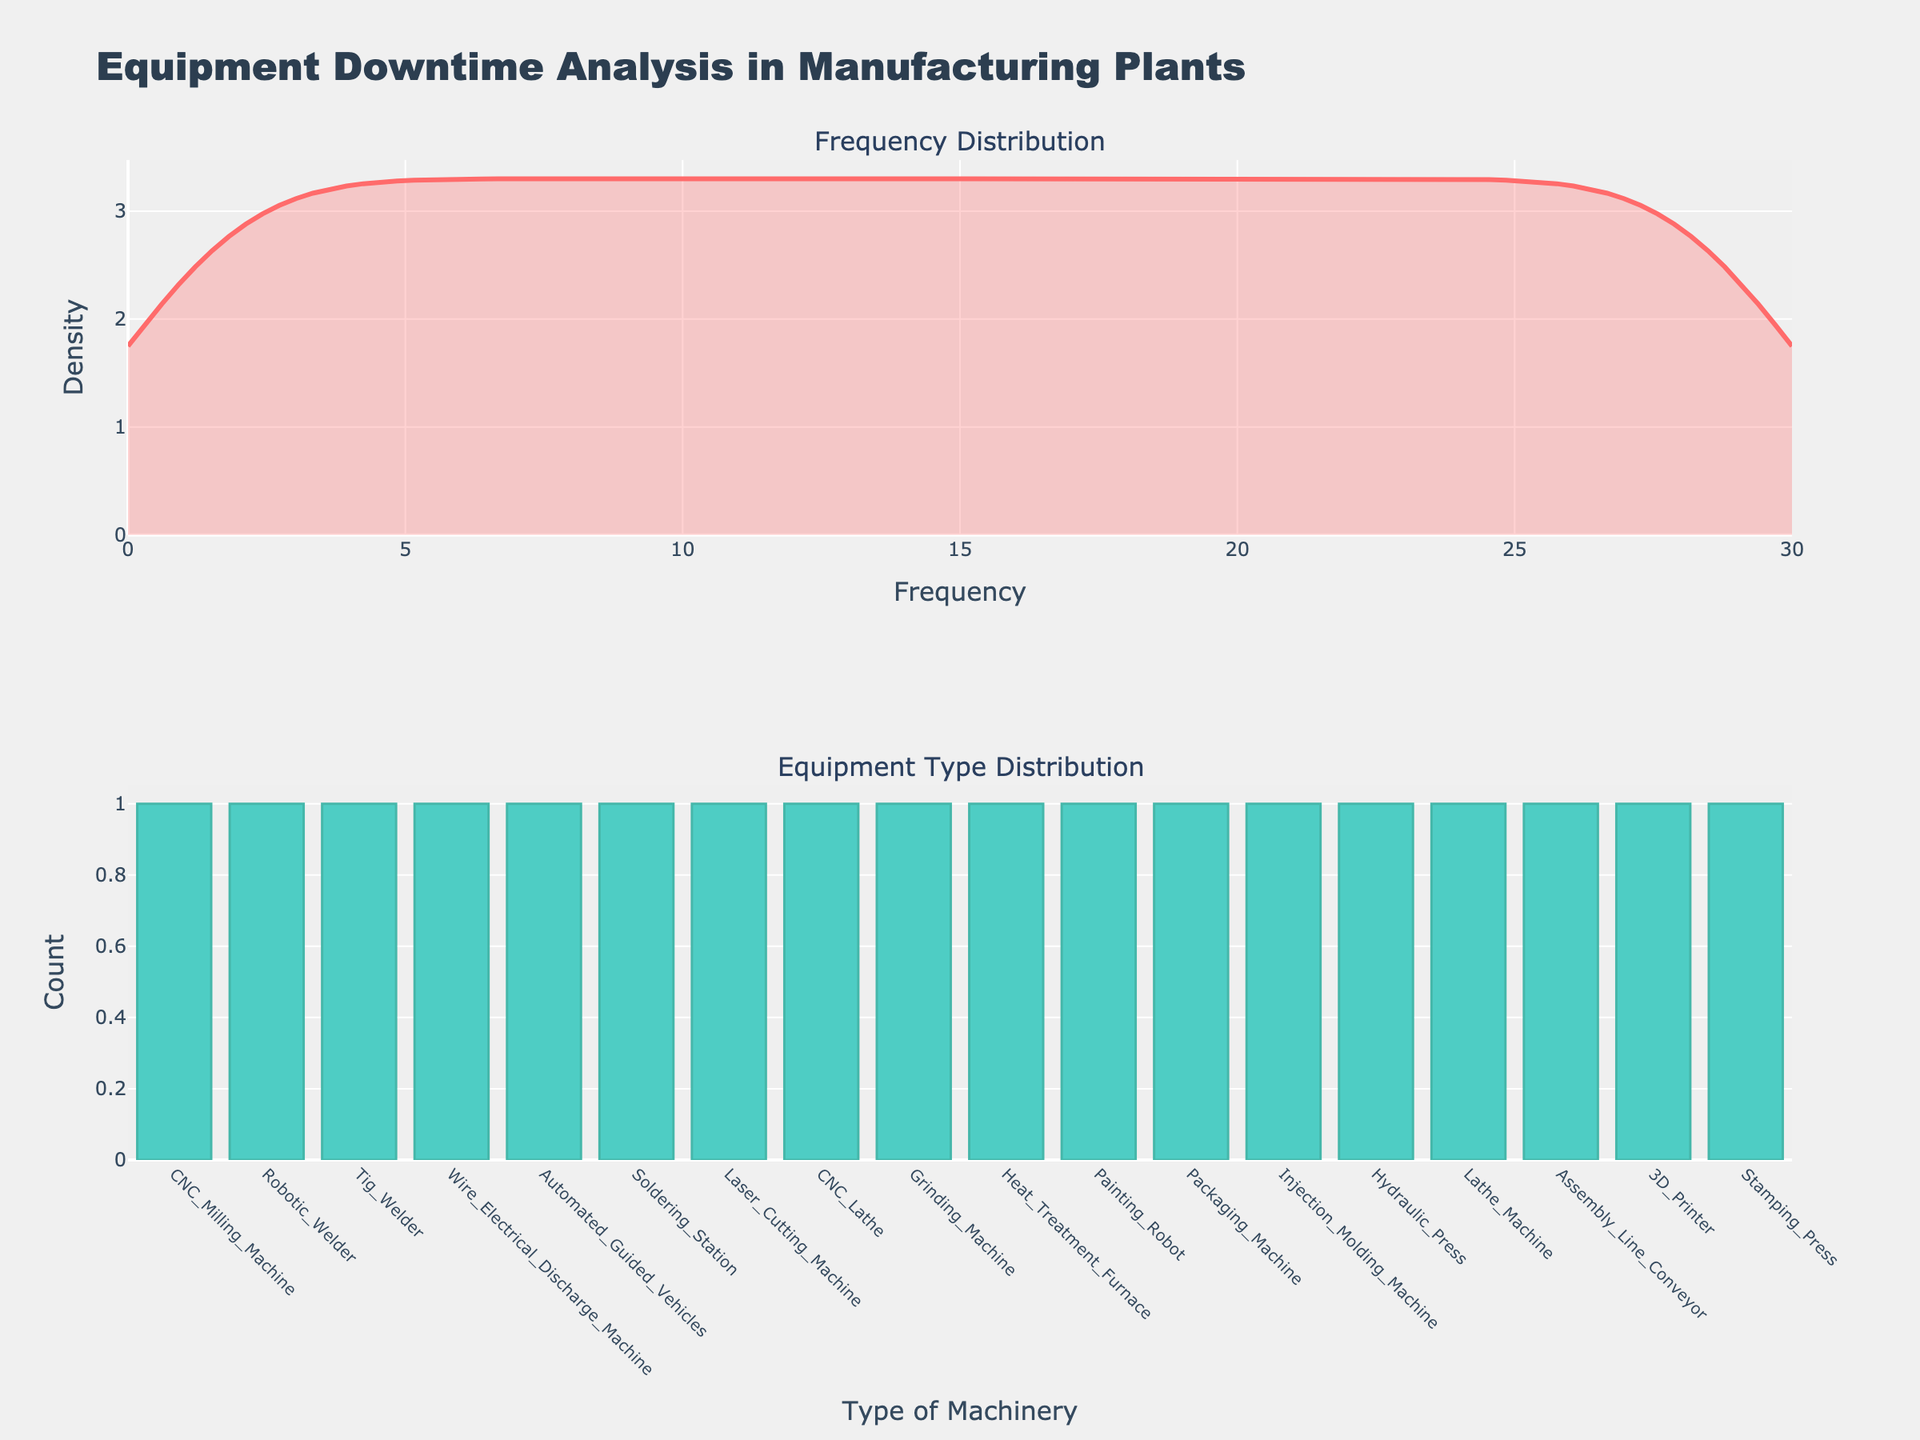What is the title of the figure? The title is located at the top of the figure and provides a summary of what the figure represents.
Answer: Equipment Downtime Analysis in Manufacturing Plants What does the x-axis on the Frequency Density plot represent? The x-axis on the Frequency Density plot is labeled "Frequency," indicating it represents the frequency of equipment downtime events.
Answer: Frequency Which type of machinery has the highest count in the Equipment Type Distribution plot? By looking at the Equipment Type Distribution plot (bar chart), the equipment type with the highest bar represents the highest count.
Answer: Packaging Machine What is the color of the line in the Frequency Density plot? The frequency density line is visually represented in the figure; its color can be identified by observation.
Answer: Red How does the count of "Laser Cutting Machine" compare to "Grinding Machine"? By looking at the Equipment Type Distribution plot, note the respective heights of the bars for "Laser Cutting Machine" and "Grinding Machine" to determine which has a higher count.
Answer: Laser Cutting Machine has a higher count What is the density value when Frequency is 15? Locate Frequency of 15 on the x-axis of the Frequency Density plot, then find the corresponding y-value which represents the density.
Answer: Approximately 0.4 What is the range of the x-axis in the Frequency Density plot? The x-axis range can be determined by looking at the minimum and maximum values of the x-axis labels.
Answer: 0 to 30 Which two types of machinery have the same count, and what is their count? Comparing the bars in the Equipment Type Distribution plot, identify the machinery types with bars of the same height and note their count.
Answer: 3D Printer and Stamping Press, both with a count of 1 What is the overall trend observed in the Frequency Density plot? Visually inspect the overall shape and behavior of the density curve in the plot to describe its trend.
Answer: Peaked around a Frequency of 15, with higher densities in the middle and tapering towards the edges What is the average frequency of the equipment downtime events? Sum all frequency values provided in the data and divide by the number of data points. Detailed calculation: (12 + 15 + 8 + 10 + 20 + 18 + 7 + 25 + 14 + 9 + 11 + 13 + 17 + 23 + 16 + 6 + 5 + 8) / 18 = 13.67
Answer: 13.67 